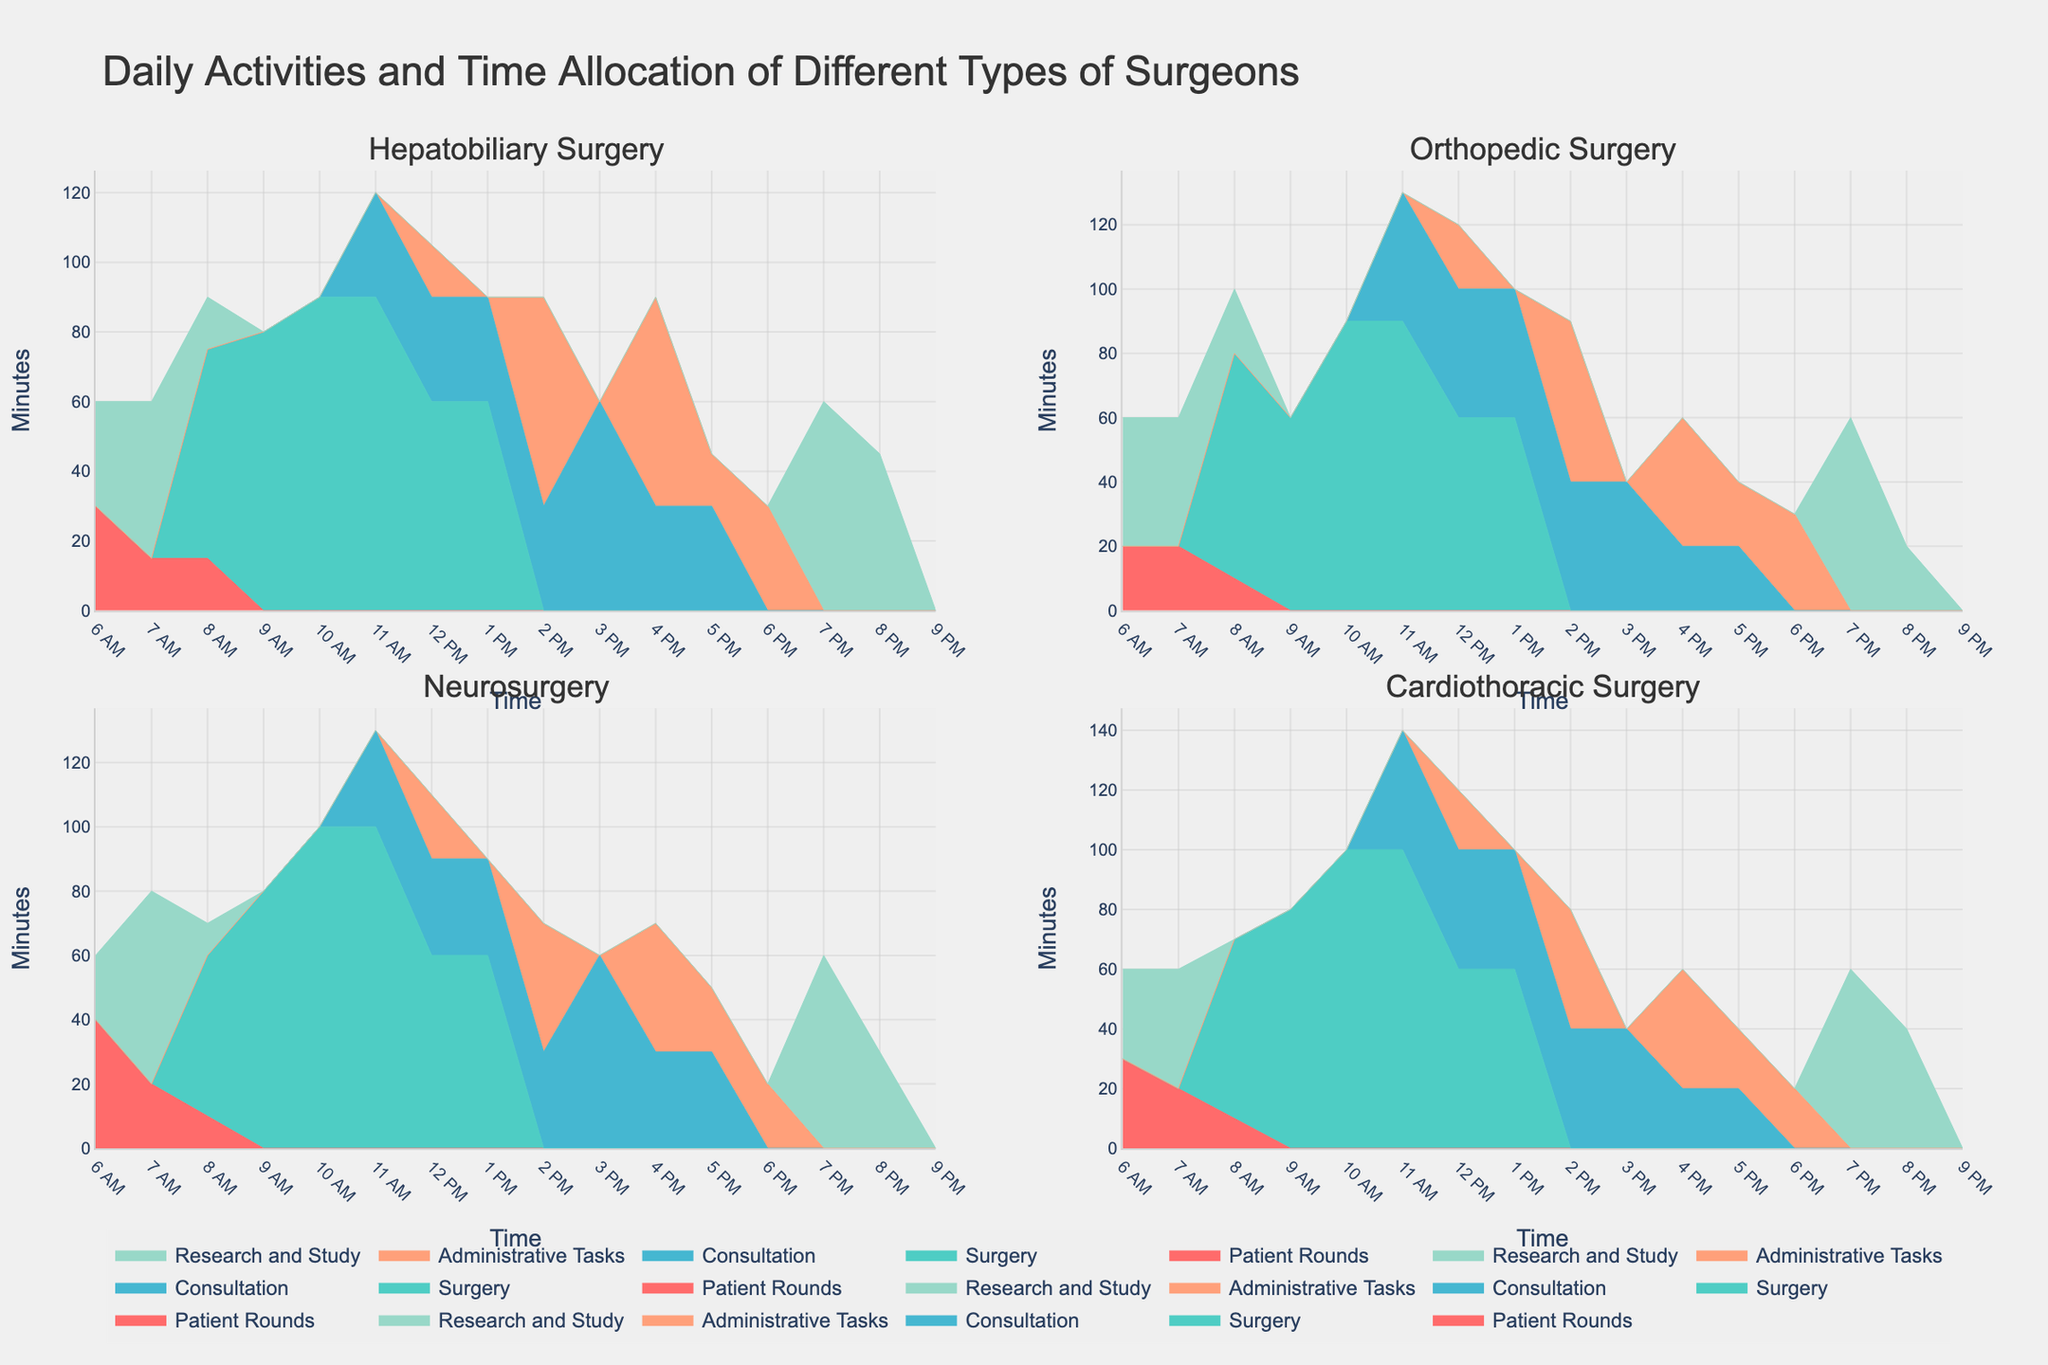What is the title of the plotted figure? The title is located at the top center of the figure, which reads "Daily Activities and Time Allocation of Different Types of Surgeons". This title summarizes the main subject of the plot.
Answer: Daily Activities and Time Allocation of Different Types of Surgeons What activities are included for Hepatobiliary Surgery? The activities specific to Hepatobiliary Surgery are listed in the legend and differentiated by unique colors. They include Patient Rounds, Surgery, Consultation, Administrative Tasks, and Research and Study.
Answer: Patient Rounds, Surgery, Consultation, Administrative Tasks, Research and Study How does the time allocation for Surgery compare between Hepatobiliary Surgery and Neurosurgery at 10 AM? At 10 AM, the figure shows that both Hepatobiliary Surgery and Neurosurgery dedicate 90 minutes to Surgery. This is visible by comparing the heights of the stacked areas for Surgery in both subplots.
Answer: They are the same What is the total time spent on Patient Rounds by Cardiothoracic Surgery from 6 AM to 8 AM? The time spent on Patient Rounds by Cardiothoracic Surgery from 6 AM to 8 AM can be calculated by adding the minutes from 6 AM (30), 7 AM (20), and 8 AM (10). So, the total is 30 + 20 + 10 minutes.
Answer: 60 minutes Which type of surgery allocates the most time to Research and Study at 7 PM? By comparing the area heights for Research and Study at 7 PM across all subplots, it is clear that Hepatobiliary Surgery allocates the most time (60 minutes) at this time.
Answer: Hepatobiliary Surgery What percentage of time does Orthopedic Surgery allocate to Administrative Tasks at 3 PM compared to Consultation? At 3 PM, Orthopedic Surgery allocates 0 minutes to Administrative Tasks and 40 minutes to Consultation. The percentage of time spent on Administrative Tasks is therefore (0 / 40) * 100%, which is 0%.
Answer: 0% How much time does each type of surgeon spend on Consultation from 12 PM to 1 PM? Checking each subplot, the time allocated to Consultation from 12 PM to 1 PM is as follows: Hepatobiliary Surgery (30 minutes), Orthopedic Surgery (40 minutes), Neurosurgery (30 minutes), and Cardiothoracic Surgery (40 minutes). Adding these up gives the total.
Answer: 140 minutes Compare the time spent on Administrative Tasks between Hepatobiliary Surgery and Orthopedic Surgery during 1 PM. At 1 PM, the subplot for Hepatobiliary Surgery shows 0 minutes allocated to Administrative Tasks, whereas Orthopedic Surgery shows 0 minutes. So, both types of surgery allocate 0 minutes to Administrative Tasks at this time.
Answer: They spend the same amount of time Which activity has the highest allocation of time across all surgeon types at 11 AM? By gauging the area heights at 11 AM in all subplots, Surgery has the highest time allocation across all surgeon types when summed.
Answer: Surgery 